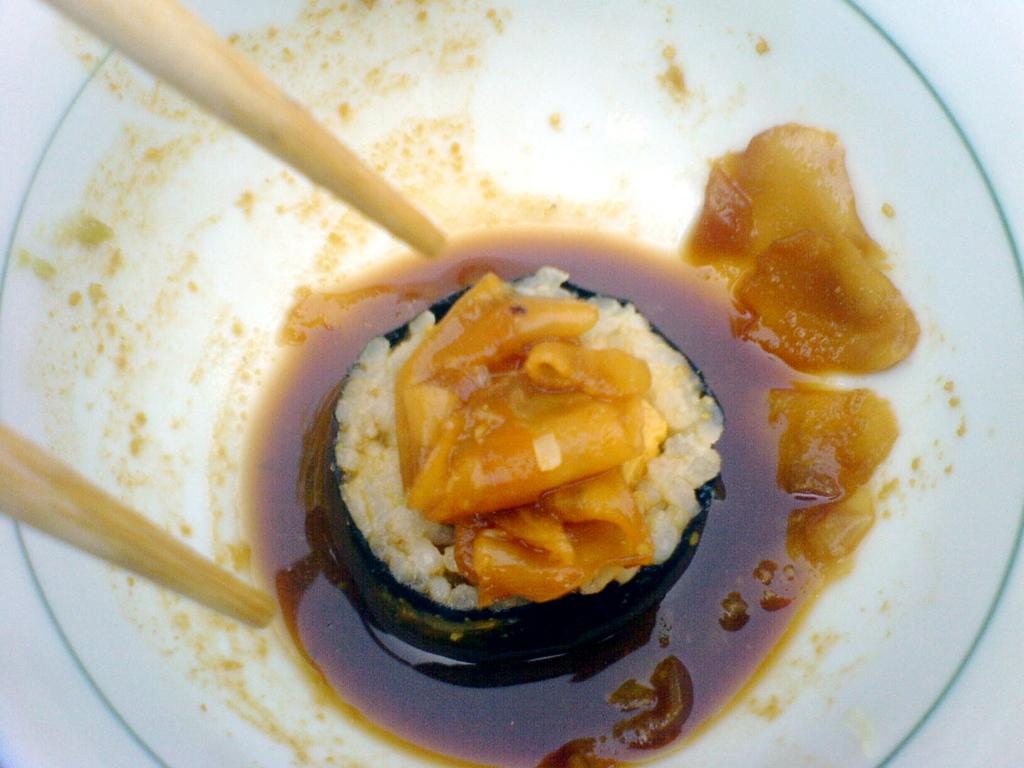What is the main subject of the image? There is a food item in the image. How is the food item presented? The food item is on a white color plate. Are there any utensils visible in the image? Yes, there is a chopstick on the left side of the plate. What type of kite is being flown by the horses in the image? There are no kites or horses present in the image; it features a food item on a white color plate with a chopstick. 